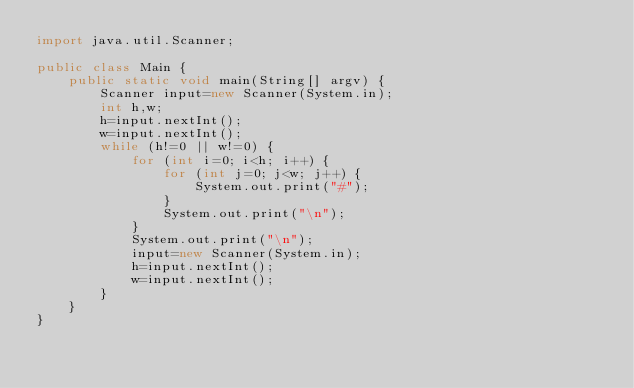Convert code to text. <code><loc_0><loc_0><loc_500><loc_500><_Java_>import java.util.Scanner;

public class Main {
    public static void main(String[] argv) {
        Scanner input=new Scanner(System.in);
        int h,w;
        h=input.nextInt();
        w=input.nextInt();
        while (h!=0 || w!=0) {
            for (int i=0; i<h; i++) {
                for (int j=0; j<w; j++) {
                    System.out.print("#");
                }
                System.out.print("\n");
            }
            System.out.print("\n");
            input=new Scanner(System.in);
            h=input.nextInt();
            w=input.nextInt();
        }
    }
}</code> 